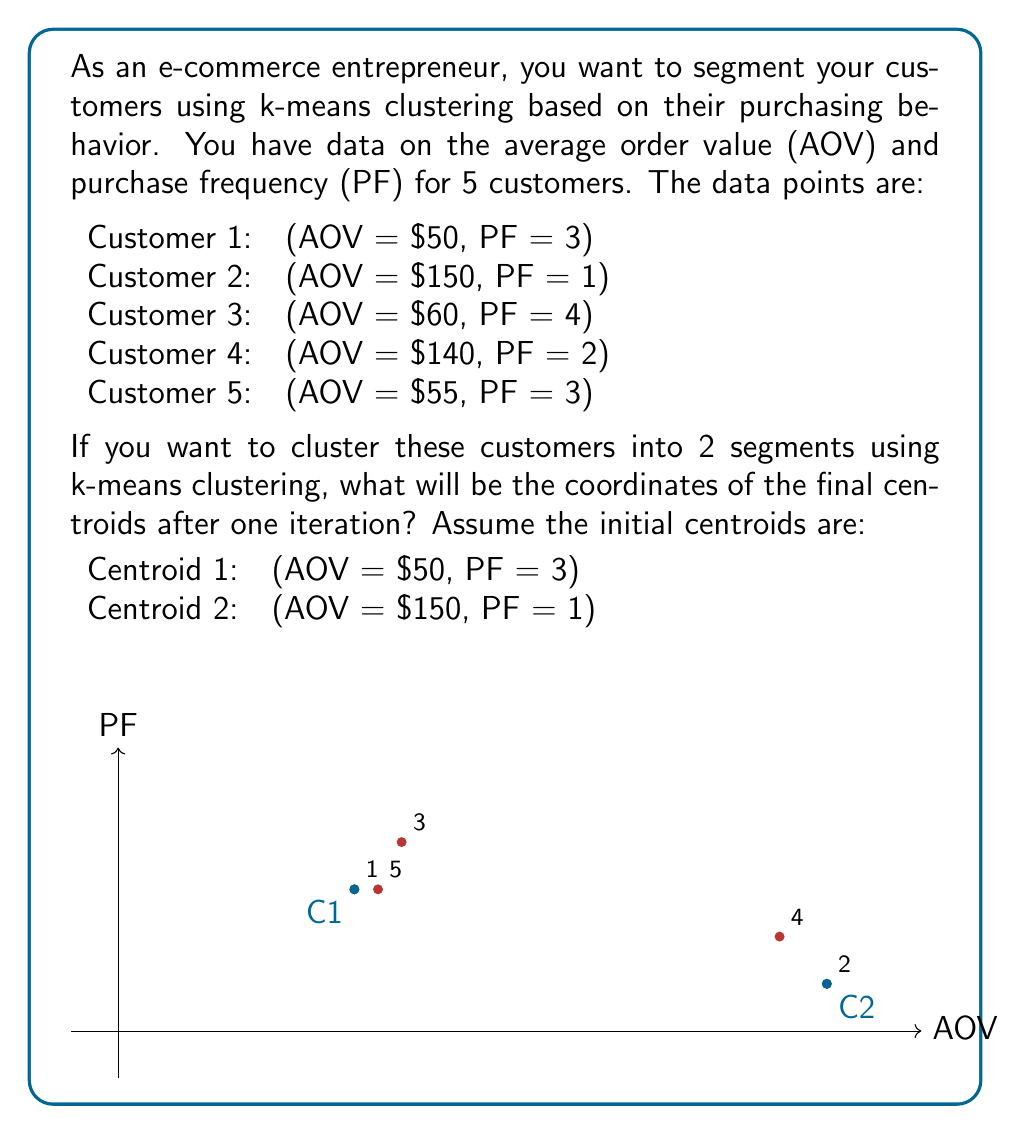Can you answer this question? Let's solve this step-by-step using the k-means clustering algorithm:

1) We start with the given initial centroids:
   Centroid 1: (50, 3)
   Centroid 2: (150, 1)

2) Assign each data point to the nearest centroid by calculating the Euclidean distance:

   For Customer 1 (50, 3):
   Distance to Centroid 1: $\sqrt{(50-50)^2 + (3-3)^2} = 0$
   Distance to Centroid 2: $\sqrt{(50-150)^2 + (3-1)^2} = 100.04$
   Assigned to Centroid 1

   For Customer 2 (150, 1):
   Distance to Centroid 1: $\sqrt{(150-50)^2 + (1-3)^2} = 100.04$
   Distance to Centroid 2: $\sqrt{(150-150)^2 + (1-1)^2} = 0$
   Assigned to Centroid 2

   For Customer 3 (60, 4):
   Distance to Centroid 1: $\sqrt{(60-50)^2 + (4-3)^2} = 10.05$
   Distance to Centroid 2: $\sqrt{(60-150)^2 + (4-1)^2} = 90.17$
   Assigned to Centroid 1

   For Customer 4 (140, 2):
   Distance to Centroid 1: $\sqrt{(140-50)^2 + (2-3)^2} = 90.06$
   Distance to Centroid 2: $\sqrt{(140-150)^2 + (2-1)^2} = 10.05$
   Assigned to Centroid 2

   For Customer 5 (55, 3):
   Distance to Centroid 1: $\sqrt{(55-50)^2 + (3-3)^2} = 5$
   Distance to Centroid 2: $\sqrt{(55-150)^2 + (3-1)^2} = 95.02$
   Assigned to Centroid 1

3) Recalculate the centroids based on the mean of the assigned points:

   Centroid 1: (Customers 1, 3, 5)
   AOV = $(50 + 60 + 55) / 3 = 55$
   PF = $(3 + 4 + 3) / 3 = 3.33$

   Centroid 2: (Customers 2, 4)
   AOV = $(150 + 140) / 2 = 145$
   PF = $(1 + 2) / 2 = 1.5$

4) The new centroids after one iteration are:
   Centroid 1: (55, 3.33)
   Centroid 2: (145, 1.5)
Answer: Centroid 1: (55, 3.33), Centroid 2: (145, 1.5) 